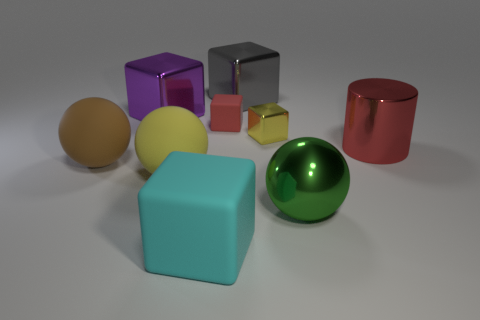Add 1 gray metal blocks. How many objects exist? 10 Subtract all metallic cubes. How many cubes are left? 2 Subtract 4 cubes. How many cubes are left? 1 Subtract all green balls. How many balls are left? 2 Subtract all cylinders. How many objects are left? 8 Add 7 small yellow objects. How many small yellow objects are left? 8 Add 6 metal spheres. How many metal spheres exist? 7 Subtract 1 brown balls. How many objects are left? 8 Subtract all purple balls. Subtract all gray cylinders. How many balls are left? 3 Subtract all large matte blocks. Subtract all large green spheres. How many objects are left? 7 